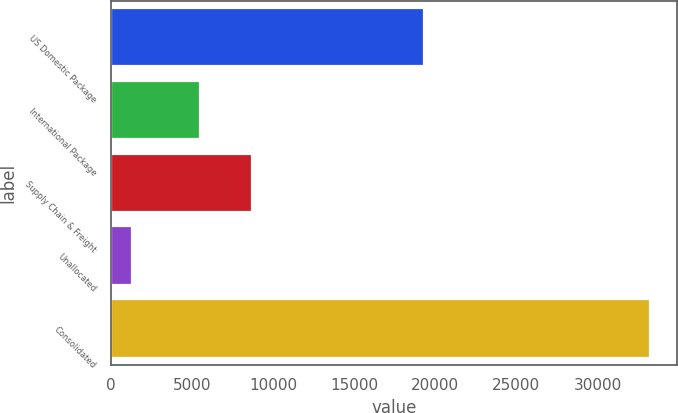Convert chart. <chart><loc_0><loc_0><loc_500><loc_500><bar_chart><fcel>US Domestic Package<fcel>International Package<fcel>Supply Chain & Freight<fcel>Unallocated<fcel>Consolidated<nl><fcel>19274<fcel>5496<fcel>8688<fcel>1290<fcel>33210<nl></chart> 